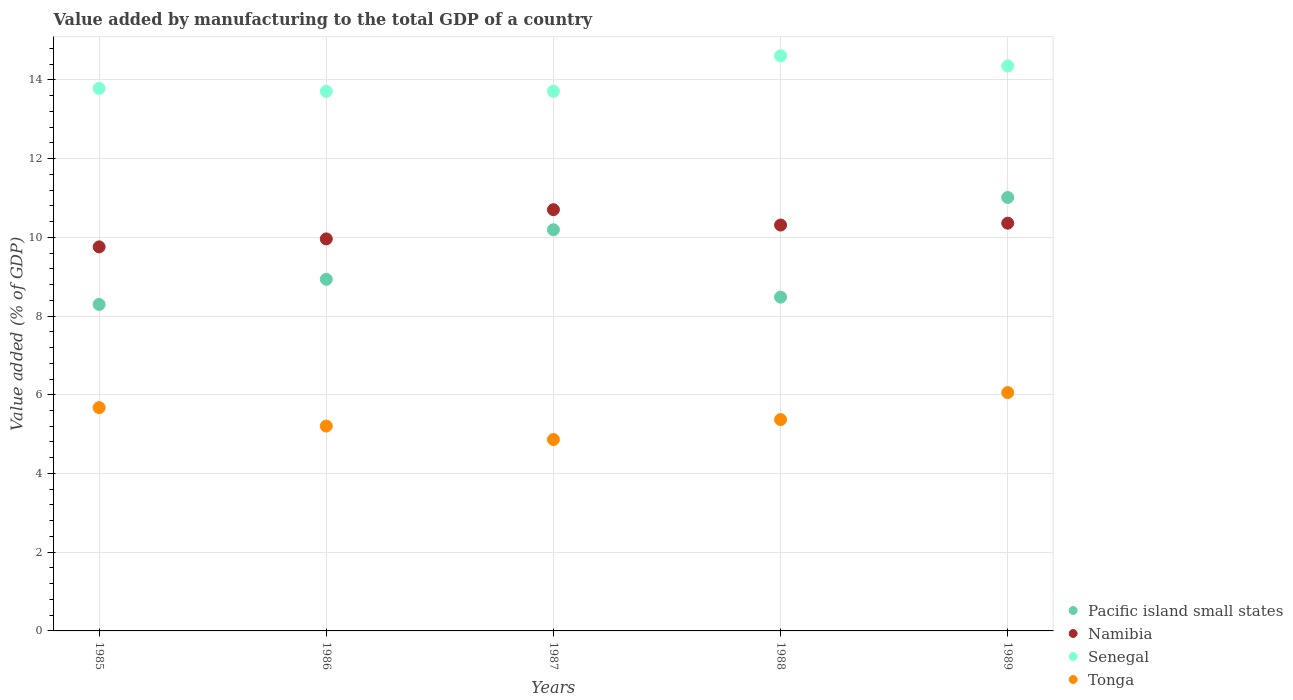What is the value added by manufacturing to the total GDP in Pacific island small states in 1989?
Your response must be concise. 11.01. Across all years, what is the maximum value added by manufacturing to the total GDP in Pacific island small states?
Offer a very short reply. 11.01. Across all years, what is the minimum value added by manufacturing to the total GDP in Pacific island small states?
Provide a succinct answer. 8.29. What is the total value added by manufacturing to the total GDP in Tonga in the graph?
Make the answer very short. 27.17. What is the difference between the value added by manufacturing to the total GDP in Pacific island small states in 1986 and that in 1987?
Keep it short and to the point. -1.26. What is the difference between the value added by manufacturing to the total GDP in Senegal in 1985 and the value added by manufacturing to the total GDP in Pacific island small states in 1987?
Provide a short and direct response. 3.59. What is the average value added by manufacturing to the total GDP in Namibia per year?
Offer a terse response. 10.22. In the year 1986, what is the difference between the value added by manufacturing to the total GDP in Pacific island small states and value added by manufacturing to the total GDP in Tonga?
Your response must be concise. 3.73. What is the ratio of the value added by manufacturing to the total GDP in Pacific island small states in 1985 to that in 1987?
Offer a terse response. 0.81. Is the value added by manufacturing to the total GDP in Namibia in 1986 less than that in 1988?
Make the answer very short. Yes. What is the difference between the highest and the second highest value added by manufacturing to the total GDP in Tonga?
Keep it short and to the point. 0.38. What is the difference between the highest and the lowest value added by manufacturing to the total GDP in Tonga?
Your response must be concise. 1.19. In how many years, is the value added by manufacturing to the total GDP in Namibia greater than the average value added by manufacturing to the total GDP in Namibia taken over all years?
Ensure brevity in your answer.  3. Is the sum of the value added by manufacturing to the total GDP in Tonga in 1986 and 1989 greater than the maximum value added by manufacturing to the total GDP in Pacific island small states across all years?
Provide a succinct answer. Yes. Is it the case that in every year, the sum of the value added by manufacturing to the total GDP in Namibia and value added by manufacturing to the total GDP in Senegal  is greater than the sum of value added by manufacturing to the total GDP in Pacific island small states and value added by manufacturing to the total GDP in Tonga?
Give a very brief answer. Yes. Is it the case that in every year, the sum of the value added by manufacturing to the total GDP in Senegal and value added by manufacturing to the total GDP in Namibia  is greater than the value added by manufacturing to the total GDP in Pacific island small states?
Provide a succinct answer. Yes. Does the value added by manufacturing to the total GDP in Namibia monotonically increase over the years?
Your answer should be very brief. No. Is the value added by manufacturing to the total GDP in Pacific island small states strictly greater than the value added by manufacturing to the total GDP in Namibia over the years?
Your answer should be compact. No. Is the value added by manufacturing to the total GDP in Pacific island small states strictly less than the value added by manufacturing to the total GDP in Tonga over the years?
Give a very brief answer. No. How many dotlines are there?
Keep it short and to the point. 4. How many years are there in the graph?
Provide a succinct answer. 5. What is the difference between two consecutive major ticks on the Y-axis?
Give a very brief answer. 2. Are the values on the major ticks of Y-axis written in scientific E-notation?
Make the answer very short. No. Does the graph contain any zero values?
Your response must be concise. No. Does the graph contain grids?
Your answer should be compact. Yes. What is the title of the graph?
Your response must be concise. Value added by manufacturing to the total GDP of a country. What is the label or title of the X-axis?
Your answer should be very brief. Years. What is the label or title of the Y-axis?
Your answer should be compact. Value added (% of GDP). What is the Value added (% of GDP) in Pacific island small states in 1985?
Your answer should be compact. 8.29. What is the Value added (% of GDP) of Namibia in 1985?
Ensure brevity in your answer.  9.76. What is the Value added (% of GDP) of Senegal in 1985?
Offer a terse response. 13.78. What is the Value added (% of GDP) in Tonga in 1985?
Your answer should be very brief. 5.67. What is the Value added (% of GDP) in Pacific island small states in 1986?
Your answer should be very brief. 8.93. What is the Value added (% of GDP) of Namibia in 1986?
Make the answer very short. 9.96. What is the Value added (% of GDP) in Senegal in 1986?
Offer a terse response. 13.71. What is the Value added (% of GDP) of Tonga in 1986?
Your response must be concise. 5.2. What is the Value added (% of GDP) in Pacific island small states in 1987?
Provide a short and direct response. 10.19. What is the Value added (% of GDP) of Namibia in 1987?
Keep it short and to the point. 10.7. What is the Value added (% of GDP) in Senegal in 1987?
Your answer should be compact. 13.71. What is the Value added (% of GDP) in Tonga in 1987?
Your answer should be very brief. 4.86. What is the Value added (% of GDP) in Pacific island small states in 1988?
Ensure brevity in your answer.  8.48. What is the Value added (% of GDP) of Namibia in 1988?
Your answer should be compact. 10.31. What is the Value added (% of GDP) of Senegal in 1988?
Provide a succinct answer. 14.61. What is the Value added (% of GDP) of Tonga in 1988?
Provide a short and direct response. 5.37. What is the Value added (% of GDP) in Pacific island small states in 1989?
Offer a very short reply. 11.01. What is the Value added (% of GDP) in Namibia in 1989?
Give a very brief answer. 10.36. What is the Value added (% of GDP) in Senegal in 1989?
Provide a short and direct response. 14.35. What is the Value added (% of GDP) in Tonga in 1989?
Provide a succinct answer. 6.06. Across all years, what is the maximum Value added (% of GDP) of Pacific island small states?
Your response must be concise. 11.01. Across all years, what is the maximum Value added (% of GDP) of Namibia?
Ensure brevity in your answer.  10.7. Across all years, what is the maximum Value added (% of GDP) in Senegal?
Ensure brevity in your answer.  14.61. Across all years, what is the maximum Value added (% of GDP) of Tonga?
Keep it short and to the point. 6.06. Across all years, what is the minimum Value added (% of GDP) of Pacific island small states?
Your answer should be compact. 8.29. Across all years, what is the minimum Value added (% of GDP) in Namibia?
Make the answer very short. 9.76. Across all years, what is the minimum Value added (% of GDP) in Senegal?
Your response must be concise. 13.71. Across all years, what is the minimum Value added (% of GDP) in Tonga?
Provide a succinct answer. 4.86. What is the total Value added (% of GDP) in Pacific island small states in the graph?
Your response must be concise. 46.91. What is the total Value added (% of GDP) in Namibia in the graph?
Keep it short and to the point. 51.09. What is the total Value added (% of GDP) of Senegal in the graph?
Offer a terse response. 70.17. What is the total Value added (% of GDP) of Tonga in the graph?
Your answer should be very brief. 27.17. What is the difference between the Value added (% of GDP) of Pacific island small states in 1985 and that in 1986?
Ensure brevity in your answer.  -0.64. What is the difference between the Value added (% of GDP) in Namibia in 1985 and that in 1986?
Keep it short and to the point. -0.2. What is the difference between the Value added (% of GDP) of Senegal in 1985 and that in 1986?
Give a very brief answer. 0.07. What is the difference between the Value added (% of GDP) in Tonga in 1985 and that in 1986?
Give a very brief answer. 0.47. What is the difference between the Value added (% of GDP) of Pacific island small states in 1985 and that in 1987?
Give a very brief answer. -1.9. What is the difference between the Value added (% of GDP) of Namibia in 1985 and that in 1987?
Your answer should be very brief. -0.94. What is the difference between the Value added (% of GDP) of Senegal in 1985 and that in 1987?
Keep it short and to the point. 0.07. What is the difference between the Value added (% of GDP) in Tonga in 1985 and that in 1987?
Provide a succinct answer. 0.81. What is the difference between the Value added (% of GDP) in Pacific island small states in 1985 and that in 1988?
Your answer should be compact. -0.19. What is the difference between the Value added (% of GDP) of Namibia in 1985 and that in 1988?
Make the answer very short. -0.55. What is the difference between the Value added (% of GDP) in Senegal in 1985 and that in 1988?
Provide a succinct answer. -0.83. What is the difference between the Value added (% of GDP) of Tonga in 1985 and that in 1988?
Your answer should be very brief. 0.3. What is the difference between the Value added (% of GDP) in Pacific island small states in 1985 and that in 1989?
Your response must be concise. -2.72. What is the difference between the Value added (% of GDP) in Namibia in 1985 and that in 1989?
Keep it short and to the point. -0.6. What is the difference between the Value added (% of GDP) of Senegal in 1985 and that in 1989?
Your answer should be compact. -0.57. What is the difference between the Value added (% of GDP) of Tonga in 1985 and that in 1989?
Keep it short and to the point. -0.38. What is the difference between the Value added (% of GDP) of Pacific island small states in 1986 and that in 1987?
Provide a succinct answer. -1.26. What is the difference between the Value added (% of GDP) of Namibia in 1986 and that in 1987?
Your answer should be very brief. -0.74. What is the difference between the Value added (% of GDP) in Senegal in 1986 and that in 1987?
Offer a terse response. -0. What is the difference between the Value added (% of GDP) of Tonga in 1986 and that in 1987?
Ensure brevity in your answer.  0.34. What is the difference between the Value added (% of GDP) of Pacific island small states in 1986 and that in 1988?
Offer a very short reply. 0.45. What is the difference between the Value added (% of GDP) of Namibia in 1986 and that in 1988?
Keep it short and to the point. -0.35. What is the difference between the Value added (% of GDP) of Senegal in 1986 and that in 1988?
Offer a very short reply. -0.9. What is the difference between the Value added (% of GDP) in Tonga in 1986 and that in 1988?
Offer a very short reply. -0.16. What is the difference between the Value added (% of GDP) in Pacific island small states in 1986 and that in 1989?
Your answer should be compact. -2.08. What is the difference between the Value added (% of GDP) of Namibia in 1986 and that in 1989?
Give a very brief answer. -0.4. What is the difference between the Value added (% of GDP) in Senegal in 1986 and that in 1989?
Offer a terse response. -0.65. What is the difference between the Value added (% of GDP) in Tonga in 1986 and that in 1989?
Offer a terse response. -0.85. What is the difference between the Value added (% of GDP) in Pacific island small states in 1987 and that in 1988?
Make the answer very short. 1.71. What is the difference between the Value added (% of GDP) of Namibia in 1987 and that in 1988?
Provide a short and direct response. 0.39. What is the difference between the Value added (% of GDP) of Senegal in 1987 and that in 1988?
Your answer should be compact. -0.9. What is the difference between the Value added (% of GDP) in Tonga in 1987 and that in 1988?
Ensure brevity in your answer.  -0.51. What is the difference between the Value added (% of GDP) of Pacific island small states in 1987 and that in 1989?
Keep it short and to the point. -0.82. What is the difference between the Value added (% of GDP) of Namibia in 1987 and that in 1989?
Give a very brief answer. 0.34. What is the difference between the Value added (% of GDP) of Senegal in 1987 and that in 1989?
Provide a short and direct response. -0.64. What is the difference between the Value added (% of GDP) of Tonga in 1987 and that in 1989?
Keep it short and to the point. -1.19. What is the difference between the Value added (% of GDP) of Pacific island small states in 1988 and that in 1989?
Give a very brief answer. -2.53. What is the difference between the Value added (% of GDP) in Namibia in 1988 and that in 1989?
Keep it short and to the point. -0.05. What is the difference between the Value added (% of GDP) in Senegal in 1988 and that in 1989?
Your answer should be very brief. 0.26. What is the difference between the Value added (% of GDP) in Tonga in 1988 and that in 1989?
Your answer should be very brief. -0.69. What is the difference between the Value added (% of GDP) in Pacific island small states in 1985 and the Value added (% of GDP) in Namibia in 1986?
Give a very brief answer. -1.67. What is the difference between the Value added (% of GDP) of Pacific island small states in 1985 and the Value added (% of GDP) of Senegal in 1986?
Your answer should be very brief. -5.41. What is the difference between the Value added (% of GDP) of Pacific island small states in 1985 and the Value added (% of GDP) of Tonga in 1986?
Make the answer very short. 3.09. What is the difference between the Value added (% of GDP) of Namibia in 1985 and the Value added (% of GDP) of Senegal in 1986?
Your response must be concise. -3.95. What is the difference between the Value added (% of GDP) of Namibia in 1985 and the Value added (% of GDP) of Tonga in 1986?
Your answer should be very brief. 4.55. What is the difference between the Value added (% of GDP) in Senegal in 1985 and the Value added (% of GDP) in Tonga in 1986?
Keep it short and to the point. 8.58. What is the difference between the Value added (% of GDP) of Pacific island small states in 1985 and the Value added (% of GDP) of Namibia in 1987?
Your answer should be compact. -2.41. What is the difference between the Value added (% of GDP) in Pacific island small states in 1985 and the Value added (% of GDP) in Senegal in 1987?
Give a very brief answer. -5.41. What is the difference between the Value added (% of GDP) of Pacific island small states in 1985 and the Value added (% of GDP) of Tonga in 1987?
Give a very brief answer. 3.43. What is the difference between the Value added (% of GDP) of Namibia in 1985 and the Value added (% of GDP) of Senegal in 1987?
Your response must be concise. -3.95. What is the difference between the Value added (% of GDP) of Namibia in 1985 and the Value added (% of GDP) of Tonga in 1987?
Offer a terse response. 4.9. What is the difference between the Value added (% of GDP) in Senegal in 1985 and the Value added (% of GDP) in Tonga in 1987?
Ensure brevity in your answer.  8.92. What is the difference between the Value added (% of GDP) in Pacific island small states in 1985 and the Value added (% of GDP) in Namibia in 1988?
Make the answer very short. -2.02. What is the difference between the Value added (% of GDP) in Pacific island small states in 1985 and the Value added (% of GDP) in Senegal in 1988?
Ensure brevity in your answer.  -6.32. What is the difference between the Value added (% of GDP) in Pacific island small states in 1985 and the Value added (% of GDP) in Tonga in 1988?
Provide a succinct answer. 2.93. What is the difference between the Value added (% of GDP) in Namibia in 1985 and the Value added (% of GDP) in Senegal in 1988?
Make the answer very short. -4.86. What is the difference between the Value added (% of GDP) in Namibia in 1985 and the Value added (% of GDP) in Tonga in 1988?
Make the answer very short. 4.39. What is the difference between the Value added (% of GDP) of Senegal in 1985 and the Value added (% of GDP) of Tonga in 1988?
Provide a short and direct response. 8.41. What is the difference between the Value added (% of GDP) in Pacific island small states in 1985 and the Value added (% of GDP) in Namibia in 1989?
Offer a very short reply. -2.06. What is the difference between the Value added (% of GDP) of Pacific island small states in 1985 and the Value added (% of GDP) of Senegal in 1989?
Ensure brevity in your answer.  -6.06. What is the difference between the Value added (% of GDP) of Pacific island small states in 1985 and the Value added (% of GDP) of Tonga in 1989?
Your response must be concise. 2.24. What is the difference between the Value added (% of GDP) in Namibia in 1985 and the Value added (% of GDP) in Senegal in 1989?
Your response must be concise. -4.6. What is the difference between the Value added (% of GDP) in Namibia in 1985 and the Value added (% of GDP) in Tonga in 1989?
Offer a terse response. 3.7. What is the difference between the Value added (% of GDP) in Senegal in 1985 and the Value added (% of GDP) in Tonga in 1989?
Provide a short and direct response. 7.73. What is the difference between the Value added (% of GDP) of Pacific island small states in 1986 and the Value added (% of GDP) of Namibia in 1987?
Ensure brevity in your answer.  -1.77. What is the difference between the Value added (% of GDP) in Pacific island small states in 1986 and the Value added (% of GDP) in Senegal in 1987?
Your answer should be very brief. -4.78. What is the difference between the Value added (% of GDP) in Pacific island small states in 1986 and the Value added (% of GDP) in Tonga in 1987?
Give a very brief answer. 4.07. What is the difference between the Value added (% of GDP) in Namibia in 1986 and the Value added (% of GDP) in Senegal in 1987?
Offer a very short reply. -3.75. What is the difference between the Value added (% of GDP) of Namibia in 1986 and the Value added (% of GDP) of Tonga in 1987?
Provide a succinct answer. 5.1. What is the difference between the Value added (% of GDP) in Senegal in 1986 and the Value added (% of GDP) in Tonga in 1987?
Make the answer very short. 8.85. What is the difference between the Value added (% of GDP) in Pacific island small states in 1986 and the Value added (% of GDP) in Namibia in 1988?
Offer a very short reply. -1.38. What is the difference between the Value added (% of GDP) in Pacific island small states in 1986 and the Value added (% of GDP) in Senegal in 1988?
Provide a succinct answer. -5.68. What is the difference between the Value added (% of GDP) of Pacific island small states in 1986 and the Value added (% of GDP) of Tonga in 1988?
Offer a very short reply. 3.56. What is the difference between the Value added (% of GDP) in Namibia in 1986 and the Value added (% of GDP) in Senegal in 1988?
Your answer should be very brief. -4.65. What is the difference between the Value added (% of GDP) in Namibia in 1986 and the Value added (% of GDP) in Tonga in 1988?
Make the answer very short. 4.59. What is the difference between the Value added (% of GDP) of Senegal in 1986 and the Value added (% of GDP) of Tonga in 1988?
Your answer should be very brief. 8.34. What is the difference between the Value added (% of GDP) of Pacific island small states in 1986 and the Value added (% of GDP) of Namibia in 1989?
Your answer should be compact. -1.43. What is the difference between the Value added (% of GDP) of Pacific island small states in 1986 and the Value added (% of GDP) of Senegal in 1989?
Ensure brevity in your answer.  -5.42. What is the difference between the Value added (% of GDP) in Pacific island small states in 1986 and the Value added (% of GDP) in Tonga in 1989?
Provide a short and direct response. 2.88. What is the difference between the Value added (% of GDP) in Namibia in 1986 and the Value added (% of GDP) in Senegal in 1989?
Offer a very short reply. -4.39. What is the difference between the Value added (% of GDP) of Namibia in 1986 and the Value added (% of GDP) of Tonga in 1989?
Make the answer very short. 3.9. What is the difference between the Value added (% of GDP) of Senegal in 1986 and the Value added (% of GDP) of Tonga in 1989?
Make the answer very short. 7.65. What is the difference between the Value added (% of GDP) in Pacific island small states in 1987 and the Value added (% of GDP) in Namibia in 1988?
Provide a short and direct response. -0.12. What is the difference between the Value added (% of GDP) in Pacific island small states in 1987 and the Value added (% of GDP) in Senegal in 1988?
Keep it short and to the point. -4.42. What is the difference between the Value added (% of GDP) of Pacific island small states in 1987 and the Value added (% of GDP) of Tonga in 1988?
Ensure brevity in your answer.  4.82. What is the difference between the Value added (% of GDP) of Namibia in 1987 and the Value added (% of GDP) of Senegal in 1988?
Offer a terse response. -3.91. What is the difference between the Value added (% of GDP) in Namibia in 1987 and the Value added (% of GDP) in Tonga in 1988?
Your answer should be very brief. 5.33. What is the difference between the Value added (% of GDP) in Senegal in 1987 and the Value added (% of GDP) in Tonga in 1988?
Ensure brevity in your answer.  8.34. What is the difference between the Value added (% of GDP) in Pacific island small states in 1987 and the Value added (% of GDP) in Namibia in 1989?
Provide a short and direct response. -0.17. What is the difference between the Value added (% of GDP) of Pacific island small states in 1987 and the Value added (% of GDP) of Senegal in 1989?
Provide a short and direct response. -4.16. What is the difference between the Value added (% of GDP) of Pacific island small states in 1987 and the Value added (% of GDP) of Tonga in 1989?
Make the answer very short. 4.14. What is the difference between the Value added (% of GDP) of Namibia in 1987 and the Value added (% of GDP) of Senegal in 1989?
Make the answer very short. -3.65. What is the difference between the Value added (% of GDP) of Namibia in 1987 and the Value added (% of GDP) of Tonga in 1989?
Your answer should be very brief. 4.65. What is the difference between the Value added (% of GDP) in Senegal in 1987 and the Value added (% of GDP) in Tonga in 1989?
Ensure brevity in your answer.  7.65. What is the difference between the Value added (% of GDP) in Pacific island small states in 1988 and the Value added (% of GDP) in Namibia in 1989?
Your response must be concise. -1.88. What is the difference between the Value added (% of GDP) in Pacific island small states in 1988 and the Value added (% of GDP) in Senegal in 1989?
Give a very brief answer. -5.87. What is the difference between the Value added (% of GDP) of Pacific island small states in 1988 and the Value added (% of GDP) of Tonga in 1989?
Keep it short and to the point. 2.42. What is the difference between the Value added (% of GDP) of Namibia in 1988 and the Value added (% of GDP) of Senegal in 1989?
Your response must be concise. -4.04. What is the difference between the Value added (% of GDP) of Namibia in 1988 and the Value added (% of GDP) of Tonga in 1989?
Ensure brevity in your answer.  4.26. What is the difference between the Value added (% of GDP) of Senegal in 1988 and the Value added (% of GDP) of Tonga in 1989?
Your response must be concise. 8.56. What is the average Value added (% of GDP) of Pacific island small states per year?
Offer a terse response. 9.38. What is the average Value added (% of GDP) in Namibia per year?
Make the answer very short. 10.22. What is the average Value added (% of GDP) of Senegal per year?
Ensure brevity in your answer.  14.03. What is the average Value added (% of GDP) of Tonga per year?
Provide a succinct answer. 5.43. In the year 1985, what is the difference between the Value added (% of GDP) of Pacific island small states and Value added (% of GDP) of Namibia?
Your answer should be compact. -1.46. In the year 1985, what is the difference between the Value added (% of GDP) of Pacific island small states and Value added (% of GDP) of Senegal?
Provide a short and direct response. -5.49. In the year 1985, what is the difference between the Value added (% of GDP) of Pacific island small states and Value added (% of GDP) of Tonga?
Provide a short and direct response. 2.62. In the year 1985, what is the difference between the Value added (% of GDP) of Namibia and Value added (% of GDP) of Senegal?
Offer a terse response. -4.02. In the year 1985, what is the difference between the Value added (% of GDP) of Namibia and Value added (% of GDP) of Tonga?
Offer a very short reply. 4.08. In the year 1985, what is the difference between the Value added (% of GDP) in Senegal and Value added (% of GDP) in Tonga?
Your answer should be compact. 8.11. In the year 1986, what is the difference between the Value added (% of GDP) of Pacific island small states and Value added (% of GDP) of Namibia?
Make the answer very short. -1.03. In the year 1986, what is the difference between the Value added (% of GDP) of Pacific island small states and Value added (% of GDP) of Senegal?
Your response must be concise. -4.78. In the year 1986, what is the difference between the Value added (% of GDP) in Pacific island small states and Value added (% of GDP) in Tonga?
Give a very brief answer. 3.73. In the year 1986, what is the difference between the Value added (% of GDP) of Namibia and Value added (% of GDP) of Senegal?
Your answer should be very brief. -3.75. In the year 1986, what is the difference between the Value added (% of GDP) of Namibia and Value added (% of GDP) of Tonga?
Provide a short and direct response. 4.75. In the year 1986, what is the difference between the Value added (% of GDP) in Senegal and Value added (% of GDP) in Tonga?
Ensure brevity in your answer.  8.5. In the year 1987, what is the difference between the Value added (% of GDP) of Pacific island small states and Value added (% of GDP) of Namibia?
Your answer should be compact. -0.51. In the year 1987, what is the difference between the Value added (% of GDP) in Pacific island small states and Value added (% of GDP) in Senegal?
Ensure brevity in your answer.  -3.52. In the year 1987, what is the difference between the Value added (% of GDP) of Pacific island small states and Value added (% of GDP) of Tonga?
Ensure brevity in your answer.  5.33. In the year 1987, what is the difference between the Value added (% of GDP) of Namibia and Value added (% of GDP) of Senegal?
Provide a short and direct response. -3.01. In the year 1987, what is the difference between the Value added (% of GDP) of Namibia and Value added (% of GDP) of Tonga?
Provide a short and direct response. 5.84. In the year 1987, what is the difference between the Value added (% of GDP) of Senegal and Value added (% of GDP) of Tonga?
Ensure brevity in your answer.  8.85. In the year 1988, what is the difference between the Value added (% of GDP) of Pacific island small states and Value added (% of GDP) of Namibia?
Offer a terse response. -1.83. In the year 1988, what is the difference between the Value added (% of GDP) of Pacific island small states and Value added (% of GDP) of Senegal?
Your answer should be very brief. -6.13. In the year 1988, what is the difference between the Value added (% of GDP) in Pacific island small states and Value added (% of GDP) in Tonga?
Your response must be concise. 3.11. In the year 1988, what is the difference between the Value added (% of GDP) of Namibia and Value added (% of GDP) of Senegal?
Your response must be concise. -4.3. In the year 1988, what is the difference between the Value added (% of GDP) of Namibia and Value added (% of GDP) of Tonga?
Keep it short and to the point. 4.94. In the year 1988, what is the difference between the Value added (% of GDP) of Senegal and Value added (% of GDP) of Tonga?
Make the answer very short. 9.24. In the year 1989, what is the difference between the Value added (% of GDP) in Pacific island small states and Value added (% of GDP) in Namibia?
Provide a short and direct response. 0.65. In the year 1989, what is the difference between the Value added (% of GDP) of Pacific island small states and Value added (% of GDP) of Senegal?
Give a very brief answer. -3.34. In the year 1989, what is the difference between the Value added (% of GDP) in Pacific island small states and Value added (% of GDP) in Tonga?
Offer a very short reply. 4.96. In the year 1989, what is the difference between the Value added (% of GDP) of Namibia and Value added (% of GDP) of Senegal?
Make the answer very short. -4. In the year 1989, what is the difference between the Value added (% of GDP) of Namibia and Value added (% of GDP) of Tonga?
Give a very brief answer. 4.3. In the year 1989, what is the difference between the Value added (% of GDP) in Senegal and Value added (% of GDP) in Tonga?
Provide a succinct answer. 8.3. What is the ratio of the Value added (% of GDP) of Pacific island small states in 1985 to that in 1986?
Offer a terse response. 0.93. What is the ratio of the Value added (% of GDP) of Namibia in 1985 to that in 1986?
Give a very brief answer. 0.98. What is the ratio of the Value added (% of GDP) of Tonga in 1985 to that in 1986?
Provide a short and direct response. 1.09. What is the ratio of the Value added (% of GDP) in Pacific island small states in 1985 to that in 1987?
Offer a very short reply. 0.81. What is the ratio of the Value added (% of GDP) of Namibia in 1985 to that in 1987?
Your response must be concise. 0.91. What is the ratio of the Value added (% of GDP) in Tonga in 1985 to that in 1987?
Offer a terse response. 1.17. What is the ratio of the Value added (% of GDP) of Pacific island small states in 1985 to that in 1988?
Keep it short and to the point. 0.98. What is the ratio of the Value added (% of GDP) of Namibia in 1985 to that in 1988?
Offer a very short reply. 0.95. What is the ratio of the Value added (% of GDP) of Senegal in 1985 to that in 1988?
Your response must be concise. 0.94. What is the ratio of the Value added (% of GDP) in Tonga in 1985 to that in 1988?
Keep it short and to the point. 1.06. What is the ratio of the Value added (% of GDP) of Pacific island small states in 1985 to that in 1989?
Ensure brevity in your answer.  0.75. What is the ratio of the Value added (% of GDP) of Namibia in 1985 to that in 1989?
Offer a terse response. 0.94. What is the ratio of the Value added (% of GDP) of Senegal in 1985 to that in 1989?
Give a very brief answer. 0.96. What is the ratio of the Value added (% of GDP) of Tonga in 1985 to that in 1989?
Your response must be concise. 0.94. What is the ratio of the Value added (% of GDP) in Pacific island small states in 1986 to that in 1987?
Keep it short and to the point. 0.88. What is the ratio of the Value added (% of GDP) in Namibia in 1986 to that in 1987?
Keep it short and to the point. 0.93. What is the ratio of the Value added (% of GDP) of Senegal in 1986 to that in 1987?
Give a very brief answer. 1. What is the ratio of the Value added (% of GDP) in Tonga in 1986 to that in 1987?
Offer a very short reply. 1.07. What is the ratio of the Value added (% of GDP) in Pacific island small states in 1986 to that in 1988?
Provide a succinct answer. 1.05. What is the ratio of the Value added (% of GDP) in Namibia in 1986 to that in 1988?
Give a very brief answer. 0.97. What is the ratio of the Value added (% of GDP) in Senegal in 1986 to that in 1988?
Give a very brief answer. 0.94. What is the ratio of the Value added (% of GDP) of Tonga in 1986 to that in 1988?
Your answer should be very brief. 0.97. What is the ratio of the Value added (% of GDP) in Pacific island small states in 1986 to that in 1989?
Provide a short and direct response. 0.81. What is the ratio of the Value added (% of GDP) of Namibia in 1986 to that in 1989?
Offer a terse response. 0.96. What is the ratio of the Value added (% of GDP) in Senegal in 1986 to that in 1989?
Give a very brief answer. 0.95. What is the ratio of the Value added (% of GDP) of Tonga in 1986 to that in 1989?
Keep it short and to the point. 0.86. What is the ratio of the Value added (% of GDP) in Pacific island small states in 1987 to that in 1988?
Offer a very short reply. 1.2. What is the ratio of the Value added (% of GDP) of Namibia in 1987 to that in 1988?
Ensure brevity in your answer.  1.04. What is the ratio of the Value added (% of GDP) of Senegal in 1987 to that in 1988?
Offer a terse response. 0.94. What is the ratio of the Value added (% of GDP) of Tonga in 1987 to that in 1988?
Give a very brief answer. 0.91. What is the ratio of the Value added (% of GDP) of Pacific island small states in 1987 to that in 1989?
Your answer should be compact. 0.93. What is the ratio of the Value added (% of GDP) in Namibia in 1987 to that in 1989?
Your response must be concise. 1.03. What is the ratio of the Value added (% of GDP) in Senegal in 1987 to that in 1989?
Offer a terse response. 0.96. What is the ratio of the Value added (% of GDP) in Tonga in 1987 to that in 1989?
Provide a succinct answer. 0.8. What is the ratio of the Value added (% of GDP) of Pacific island small states in 1988 to that in 1989?
Provide a short and direct response. 0.77. What is the ratio of the Value added (% of GDP) in Senegal in 1988 to that in 1989?
Give a very brief answer. 1.02. What is the ratio of the Value added (% of GDP) of Tonga in 1988 to that in 1989?
Keep it short and to the point. 0.89. What is the difference between the highest and the second highest Value added (% of GDP) in Pacific island small states?
Your response must be concise. 0.82. What is the difference between the highest and the second highest Value added (% of GDP) of Namibia?
Keep it short and to the point. 0.34. What is the difference between the highest and the second highest Value added (% of GDP) in Senegal?
Provide a short and direct response. 0.26. What is the difference between the highest and the second highest Value added (% of GDP) of Tonga?
Provide a succinct answer. 0.38. What is the difference between the highest and the lowest Value added (% of GDP) of Pacific island small states?
Your answer should be compact. 2.72. What is the difference between the highest and the lowest Value added (% of GDP) of Namibia?
Your answer should be very brief. 0.94. What is the difference between the highest and the lowest Value added (% of GDP) in Senegal?
Offer a very short reply. 0.9. What is the difference between the highest and the lowest Value added (% of GDP) of Tonga?
Keep it short and to the point. 1.19. 